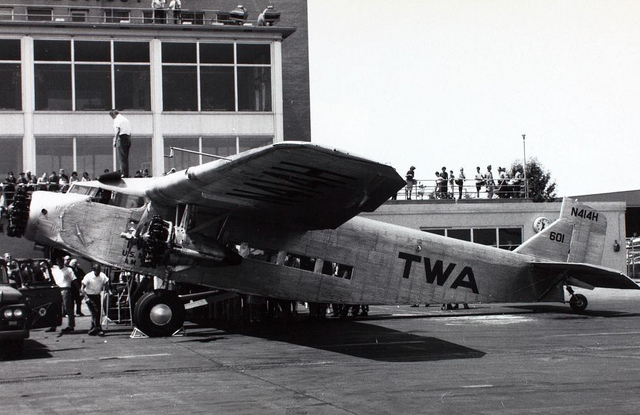Identify and read out the text in this image. HA TWA N414H 601 